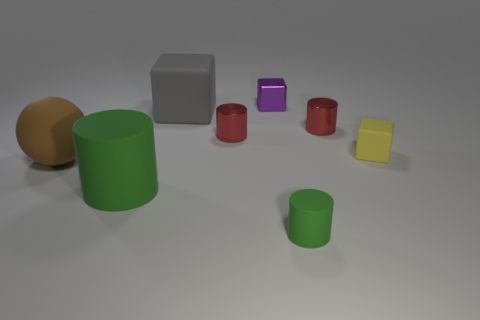Are there any other things that are the same shape as the brown thing?
Ensure brevity in your answer.  No. There is a green thing that is the same size as the yellow matte block; what is its material?
Provide a succinct answer. Rubber. Is the yellow matte thing the same size as the purple metal object?
Offer a very short reply. Yes. There is a big rubber thing that is behind the small rubber thing behind the large green matte thing; are there any blocks that are in front of it?
Give a very brief answer. Yes. What is the material of the big gray object that is the same shape as the small yellow thing?
Make the answer very short. Rubber. What number of cubes are in front of the tiny red cylinder that is left of the purple cube?
Offer a very short reply. 1. There is a shiny cylinder on the right side of the red thing on the left side of the block behind the big matte block; what is its size?
Keep it short and to the point. Small. There is a object that is behind the rubber block on the left side of the yellow matte thing; what color is it?
Provide a short and direct response. Purple. How many other objects are there of the same material as the gray cube?
Offer a very short reply. 4. What number of other objects are there of the same color as the big cylinder?
Make the answer very short. 1. 